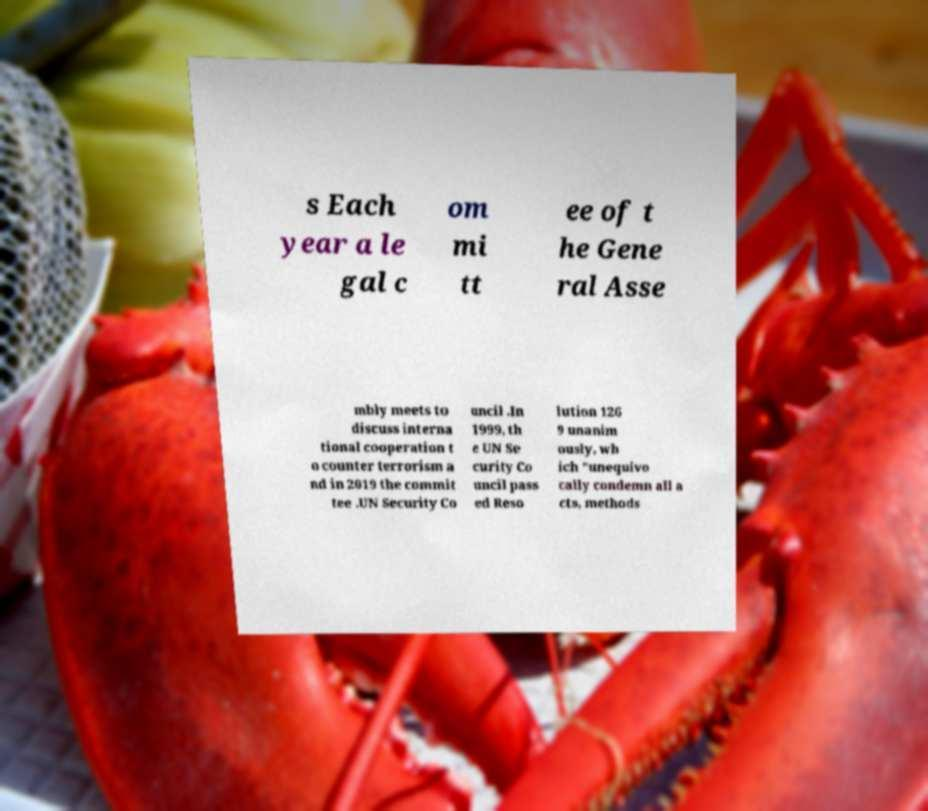Could you assist in decoding the text presented in this image and type it out clearly? s Each year a le gal c om mi tt ee of t he Gene ral Asse mbly meets to discuss interna tional cooperation t o counter terrorism a nd in 2019 the commit tee .UN Security Co uncil .In 1999, th e UN Se curity Co uncil pass ed Reso lution 126 9 unanim ously, wh ich "unequivo cally condemn all a cts, methods 